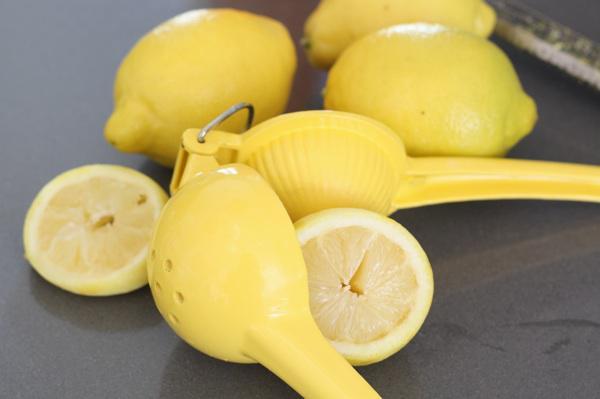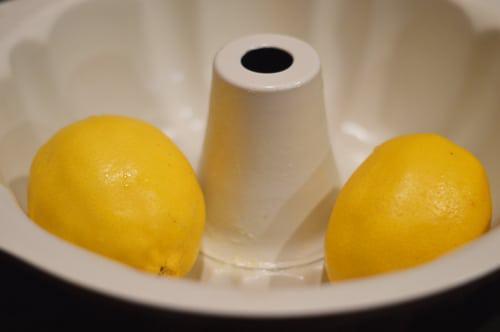The first image is the image on the left, the second image is the image on the right. Analyze the images presented: Is the assertion "The left image shows sliced fruit and the right image shows whole fruit." valid? Answer yes or no. Yes. The first image is the image on the left, the second image is the image on the right. For the images shown, is this caption "There are only two whole lemons in one of the images." true? Answer yes or no. Yes. 